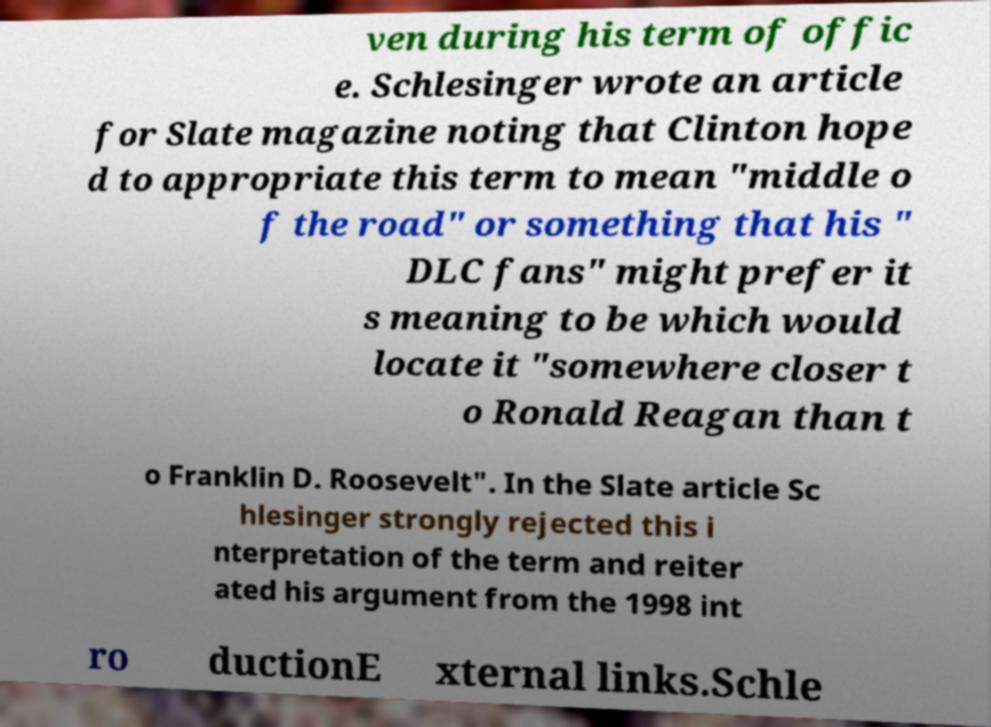Please read and relay the text visible in this image. What does it say? ven during his term of offic e. Schlesinger wrote an article for Slate magazine noting that Clinton hope d to appropriate this term to mean "middle o f the road" or something that his " DLC fans" might prefer it s meaning to be which would locate it "somewhere closer t o Ronald Reagan than t o Franklin D. Roosevelt". In the Slate article Sc hlesinger strongly rejected this i nterpretation of the term and reiter ated his argument from the 1998 int ro ductionE xternal links.Schle 